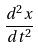<formula> <loc_0><loc_0><loc_500><loc_500>\frac { d ^ { 2 } x } { d t ^ { 2 } }</formula> 